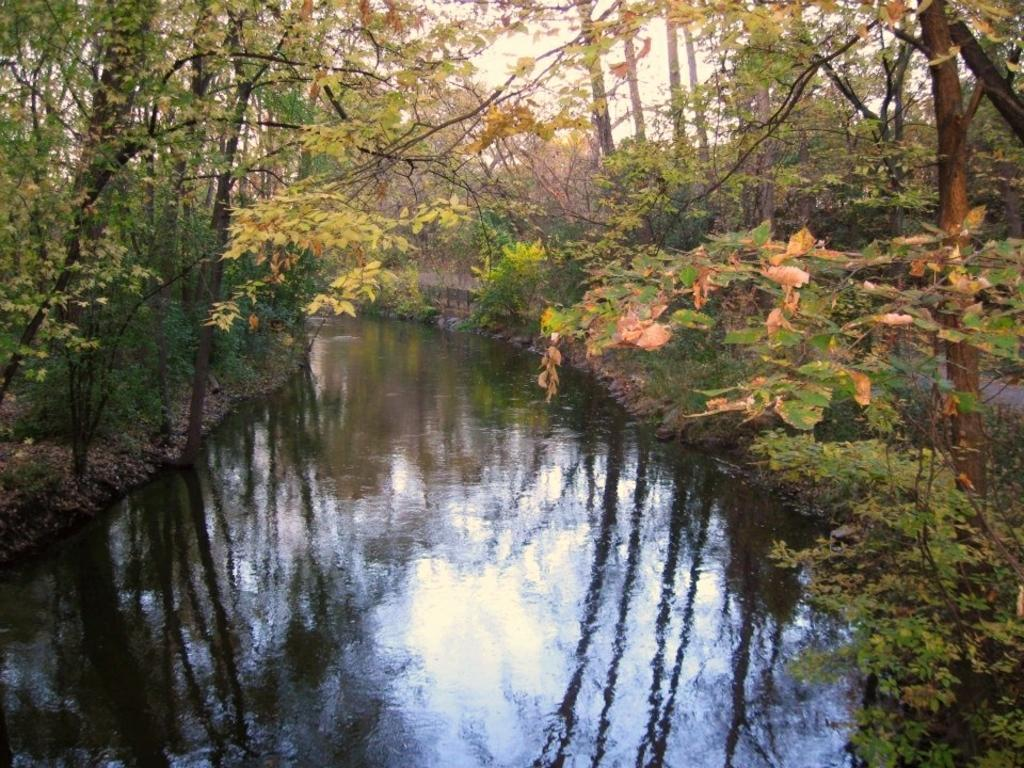What type of vegetation can be seen in the image? There are trees and plants in the image. What natural element is visible in the image? Water is visible in the image. What can be seen in the background of the image? The sky is visible in the background of the image. What type of food is being prepared in the image? There is no food preparation visible in the image; it primarily features vegetation and natural elements. How many clocks are present in the image? There are no clocks visible in the image. 